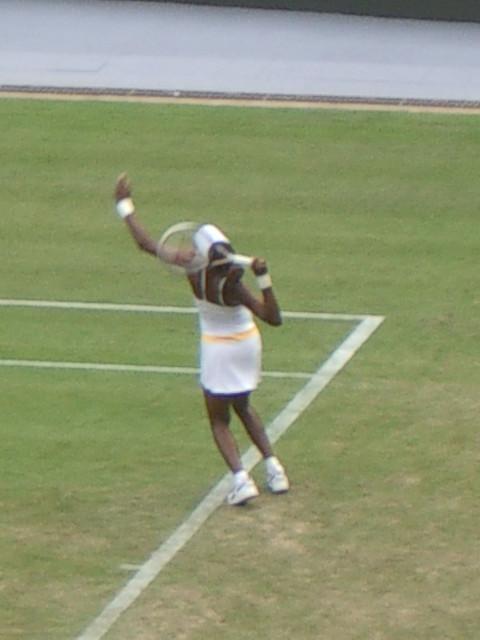What color is her dress?
Answer briefly. White. What sport is being played?
Give a very brief answer. Tennis. What game is being played?
Be succinct. Tennis. Is this a clay tennis court?
Quick response, please. No. 